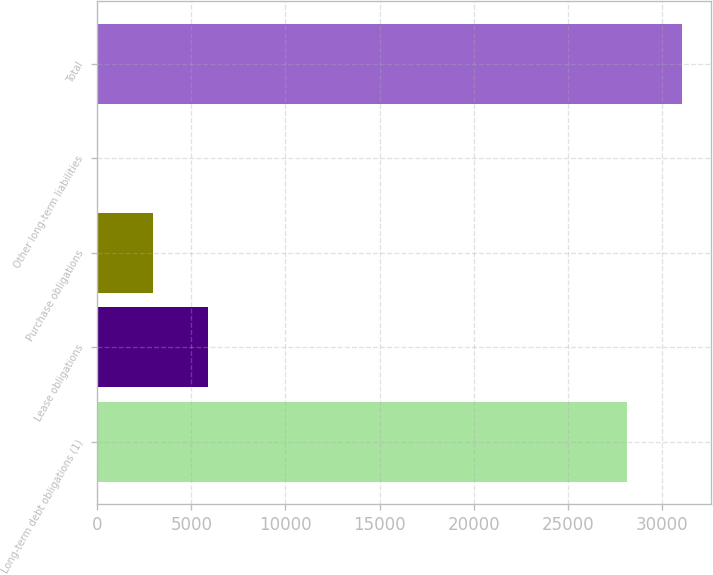Convert chart to OTSL. <chart><loc_0><loc_0><loc_500><loc_500><bar_chart><fcel>Long-term debt obligations (1)<fcel>Lease obligations<fcel>Purchase obligations<fcel>Other long-term liabilities<fcel>Total<nl><fcel>28132<fcel>5894.8<fcel>2964.9<fcel>35<fcel>31061.9<nl></chart> 